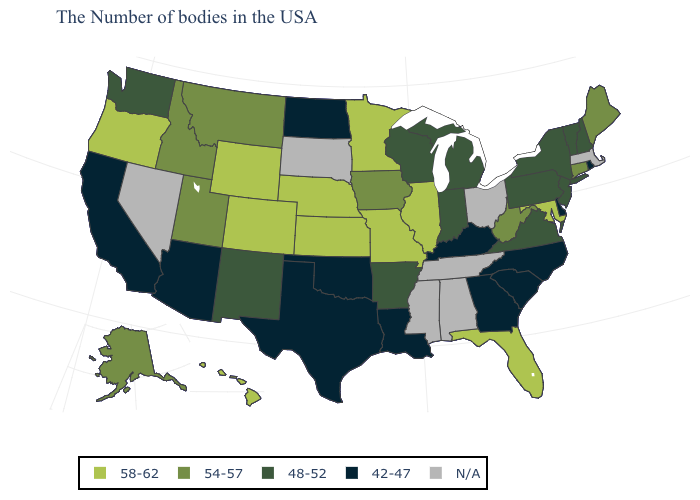What is the highest value in the USA?
Keep it brief. 58-62. What is the value of Virginia?
Be succinct. 48-52. Among the states that border Georgia , does Florida have the highest value?
Keep it brief. Yes. Among the states that border Nevada , does Idaho have the highest value?
Give a very brief answer. No. Which states hav the highest value in the Northeast?
Short answer required. Maine, Connecticut. Which states have the lowest value in the USA?
Concise answer only. Rhode Island, Delaware, North Carolina, South Carolina, Georgia, Kentucky, Louisiana, Oklahoma, Texas, North Dakota, Arizona, California. Is the legend a continuous bar?
Quick response, please. No. Name the states that have a value in the range N/A?
Give a very brief answer. Massachusetts, Ohio, Alabama, Tennessee, Mississippi, South Dakota, Nevada. Which states have the lowest value in the USA?
Give a very brief answer. Rhode Island, Delaware, North Carolina, South Carolina, Georgia, Kentucky, Louisiana, Oklahoma, Texas, North Dakota, Arizona, California. What is the value of Georgia?
Be succinct. 42-47. What is the lowest value in states that border Nevada?
Keep it brief. 42-47. Among the states that border Colorado , does Oklahoma have the lowest value?
Concise answer only. Yes. Name the states that have a value in the range 48-52?
Give a very brief answer. New Hampshire, Vermont, New York, New Jersey, Pennsylvania, Virginia, Michigan, Indiana, Wisconsin, Arkansas, New Mexico, Washington. 